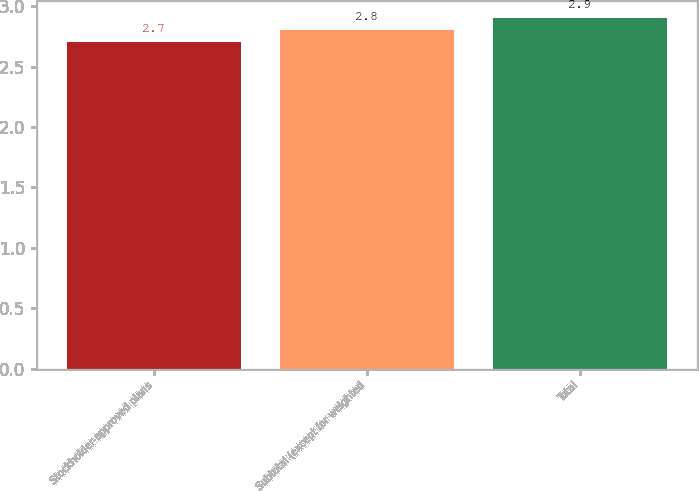Convert chart. <chart><loc_0><loc_0><loc_500><loc_500><bar_chart><fcel>Stockholder-approved plans<fcel>Subtotal (except for weighted<fcel>Total<nl><fcel>2.7<fcel>2.8<fcel>2.9<nl></chart> 